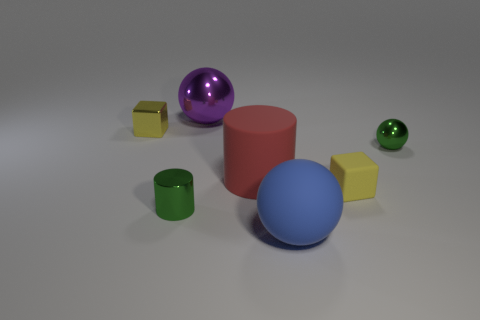Subtract all purple metal spheres. How many spheres are left? 2 Add 1 big red cylinders. How many objects exist? 8 Subtract 2 blocks. How many blocks are left? 0 Subtract all green cylinders. How many cylinders are left? 1 Subtract all blocks. How many objects are left? 5 Subtract all cyan balls. Subtract all blue blocks. How many balls are left? 3 Subtract all large yellow metal cubes. Subtract all spheres. How many objects are left? 4 Add 7 tiny green cylinders. How many tiny green cylinders are left? 8 Add 7 green shiny balls. How many green shiny balls exist? 8 Subtract 0 yellow cylinders. How many objects are left? 7 